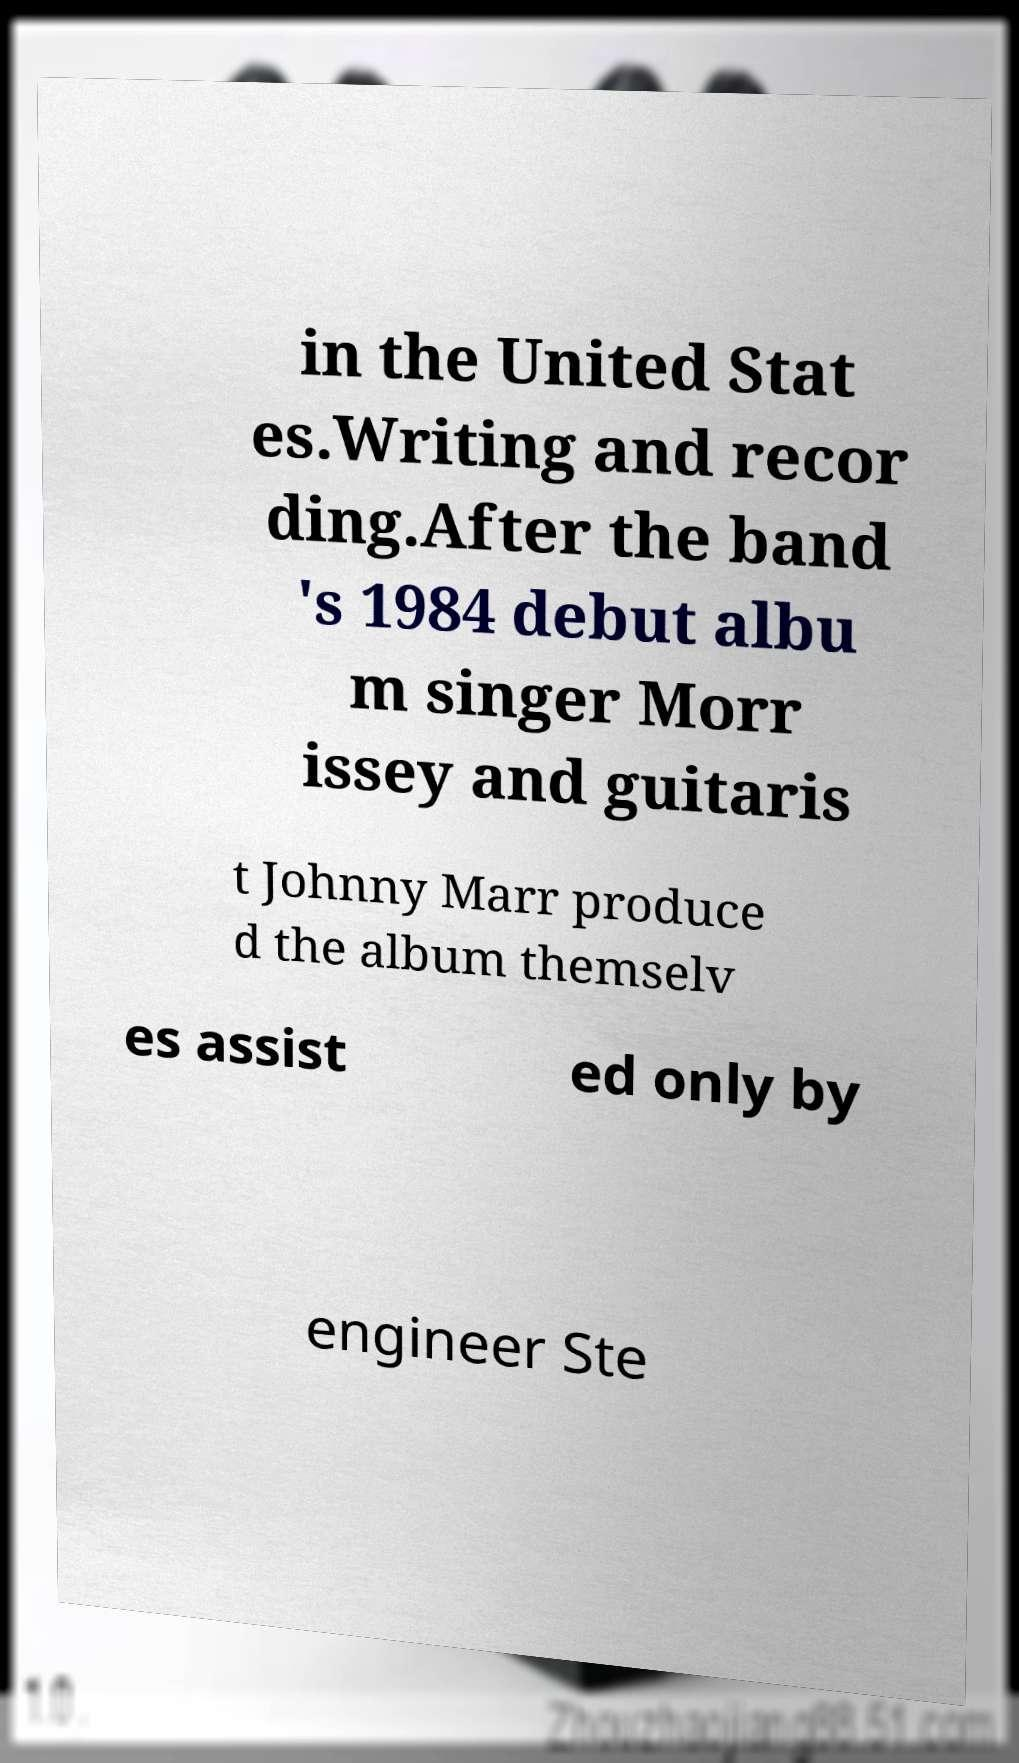For documentation purposes, I need the text within this image transcribed. Could you provide that? in the United Stat es.Writing and recor ding.After the band 's 1984 debut albu m singer Morr issey and guitaris t Johnny Marr produce d the album themselv es assist ed only by engineer Ste 